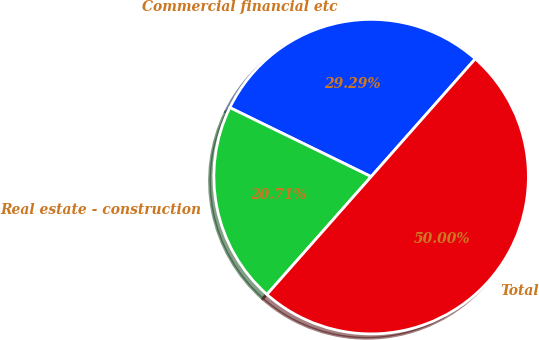<chart> <loc_0><loc_0><loc_500><loc_500><pie_chart><fcel>Commercial financial etc<fcel>Real estate - construction<fcel>Total<nl><fcel>29.29%<fcel>20.71%<fcel>50.0%<nl></chart> 